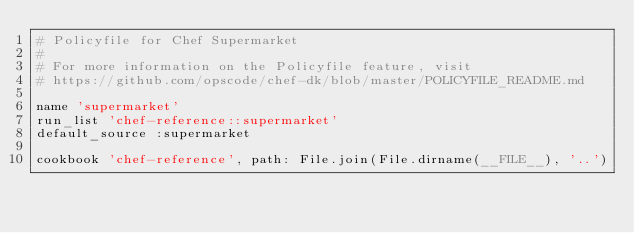Convert code to text. <code><loc_0><loc_0><loc_500><loc_500><_Ruby_># Policyfile for Chef Supermarket
#
# For more information on the Policyfile feature, visit
# https://github.com/opscode/chef-dk/blob/master/POLICYFILE_README.md

name 'supermarket'
run_list 'chef-reference::supermarket'
default_source :supermarket

cookbook 'chef-reference', path: File.join(File.dirname(__FILE__), '..')
</code> 